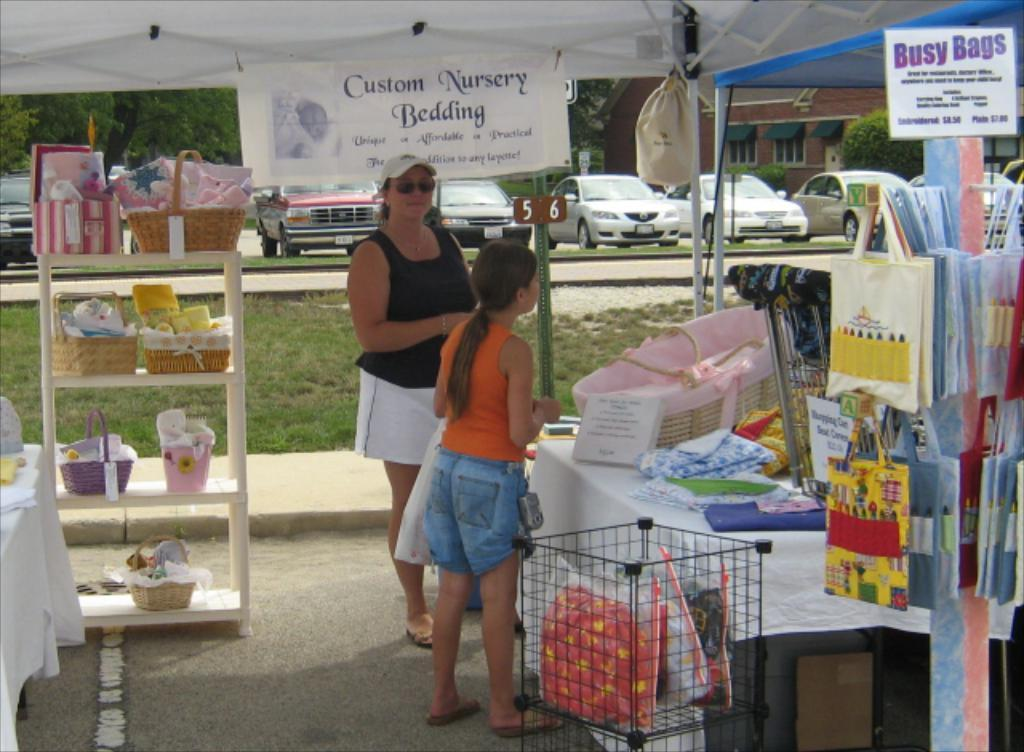How many people are visible in the image? There are people in the image, but the exact number cannot be determined from the provided facts. What type of surface is visible in the image? There is grass in the image, which suggests that the surface is grassy. What is the rack used for in the image? The rack is used for holding or storing items, as indicated by the presence of baskets on it. What might be used to clean or wipe in the image? Napkins are present in the image for cleaning or wiping. What is the purpose of the mesh container in the image? The mesh container is likely used for holding or storing items, as it is present in the image alongside other containers and objects. What type of structure is visible in the image? There is a tent in the image, which suggests that it is a temporary or portable shelter. What type of transportation is visible in the image? There are cars in the image, which indicates that there is a road nearby. What type of vegetation is visible in the image? There are trees and plants in the image, which suggests a natural or outdoor setting. What type of building is visible in the image? There is a house in the image, which indicates a residential or domestic setting. What type of objects are present in the image? There are baskets, a tablecloth, a mesh container, bags, posters, a banner, a pole, a tent, a road, cars, trees, plants, windows, and other objects in the image. What type of wrench is being used to fix the army's growth in the image? There is no wrench, army, or growth present in the image. 